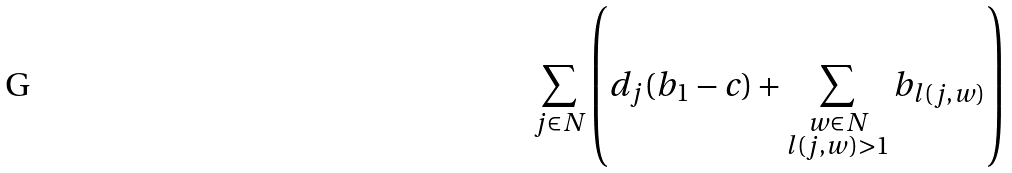<formula> <loc_0><loc_0><loc_500><loc_500>\sum _ { j \in N } \left ( d _ { j } ( b _ { 1 } - c ) + \sum _ { \substack { w \in N \\ l ( j , w ) > 1 } } { b _ { l ( j , w ) } } \right )</formula> 